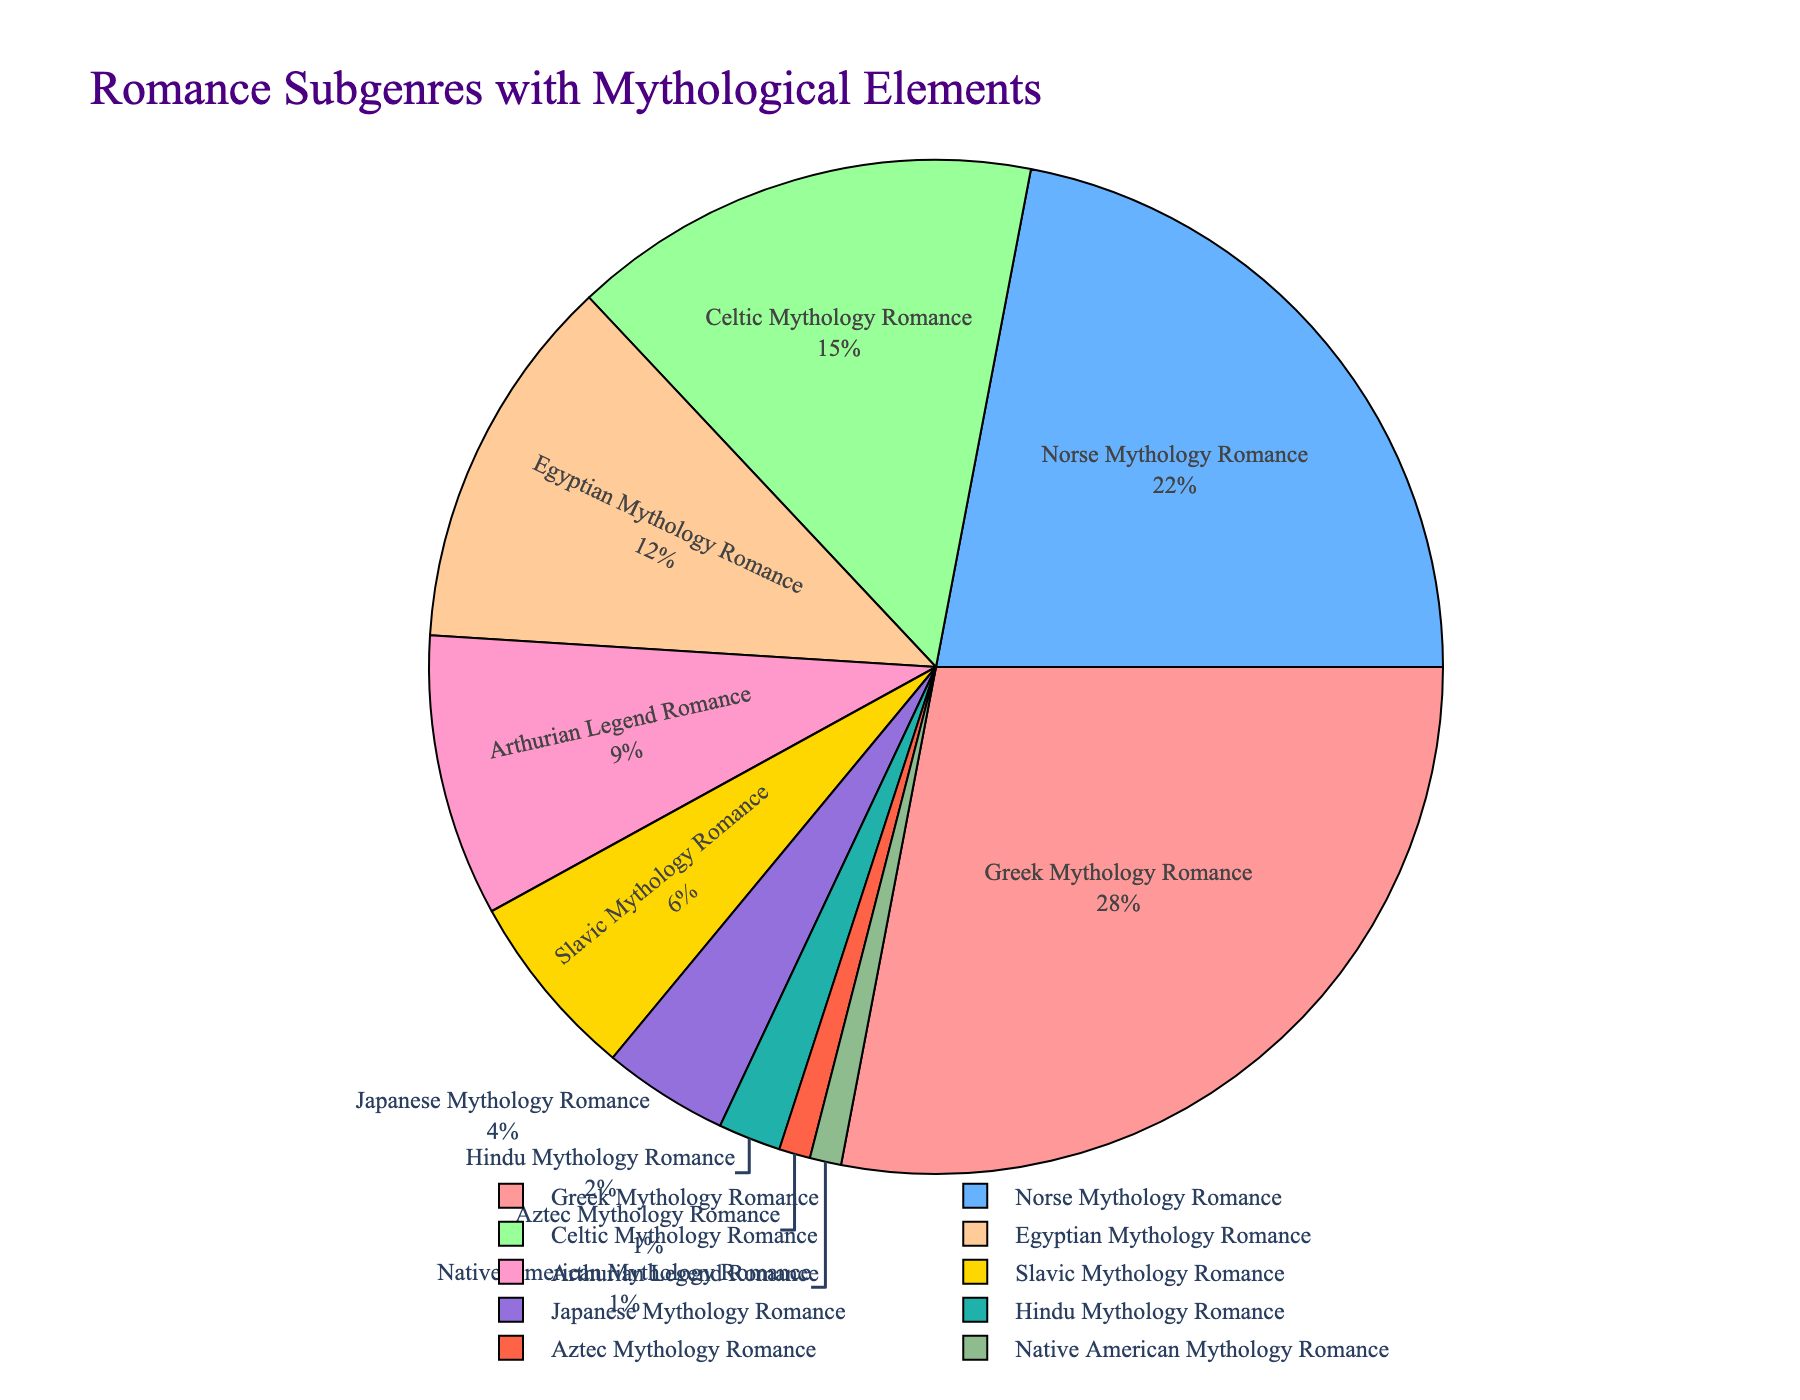Which subgenre has the largest sales percentage? The subgenre with the largest slice in the pie chart is Greek Mythology Romance.
Answer: Greek Mythology Romance How does the sales percentage of Norse Mythology Romance compare to Greek Mythology Romance? Greek Mythology Romance has a 28% sales percentage, which is 6% higher than the 22% sales percentage of Norse Mythology Romance.
Answer: Greek Mythology Romance has 6% more What is the combined sales percentage of Celtic, Egyptian, and Arthurian Legend Romance? Celtic Mythology Romance has 15%, Egyptian Mythology Romance has 12%, and Arthurian Legend Romance has 9%. Adding these together gives 15 + 12 + 9 = 36%.
Answer: 36% Which subgenre has the smallest sales percentage? The smallest slices in the pie chart are Aztec Mythology Romance and Native American Mythology Romance, both with 1%.
Answer: Aztec Mythology Romance and Native American Mythology Romance How many subgenres have a sales percentage greater than 10%? The subgenres with sales percentages greater than 10% are Greek Mythology Romance (28%), Norse Mythology Romance (22%), Celtic Mythology Romance (15%), and Egyptian Mythology Romance (12%). There are 4 subgenres in total.
Answer: 4 What is the difference in sales percentage between Slavic Mythology Romance and Japanese Mythology Romance? Slavic Mythology Romance has 6% and Japanese Mythology Romance has 4%. The difference is 6% - 4% = 2%.
Answer: 2% Which subgenre has a sales percentage equal to half of Another Subgenre’s percentage? Hindu Mythology Romance has 2%, which is half of Celtic Mythology Romance's 4%.
Answer: Hindu Mythology Romance is half of Celtic Mythology Romance Between Greek and Norse Mythology Romances, which has the larger sales percentage and by how much? Greek Mythology Romance (28%) has a larger sales percentage than Norse Mythology Romance (22%) by 28% - 22% = 6%.
Answer: Greek Mythology Romance by 6% Which subgenres are represented by the colors green and blue? The subgenre colored blue is Norse Mythology Romance, and the subgenre colored green is Celtic Mythology Romance.
Answer: Norse Mythology Romance (blue), Celtic Mythology Romance (green) What is the combined sales percentage of subgenres with less than 5% sales? The subgenres with less than 5% sales are Japanese Mythology Romance (4%), Hindu Mythology Romance (2%), Aztec Mythology Romance (1%), and Native American Mythology Romance (1%), and their combined percentage is 4 + 2 + 1 + 1 = 8%.
Answer: 8% 